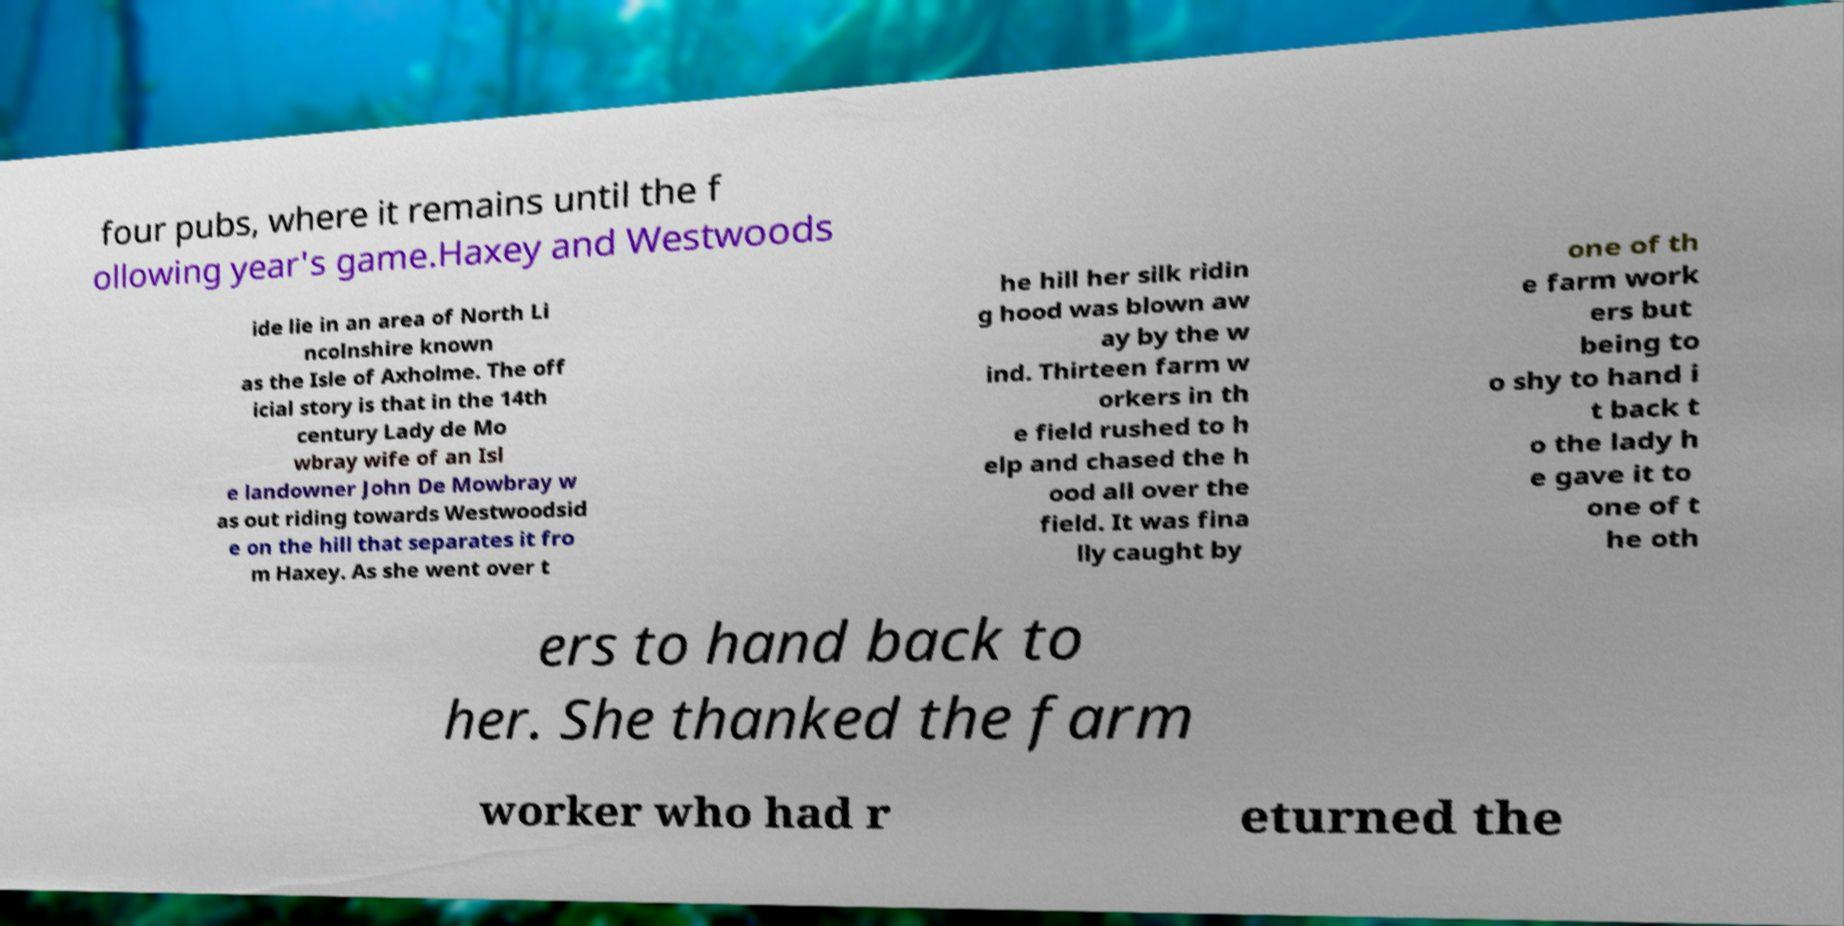Please identify and transcribe the text found in this image. four pubs, where it remains until the f ollowing year's game.Haxey and Westwoods ide lie in an area of North Li ncolnshire known as the Isle of Axholme. The off icial story is that in the 14th century Lady de Mo wbray wife of an Isl e landowner John De Mowbray w as out riding towards Westwoodsid e on the hill that separates it fro m Haxey. As she went over t he hill her silk ridin g hood was blown aw ay by the w ind. Thirteen farm w orkers in th e field rushed to h elp and chased the h ood all over the field. It was fina lly caught by one of th e farm work ers but being to o shy to hand i t back t o the lady h e gave it to one of t he oth ers to hand back to her. She thanked the farm worker who had r eturned the 